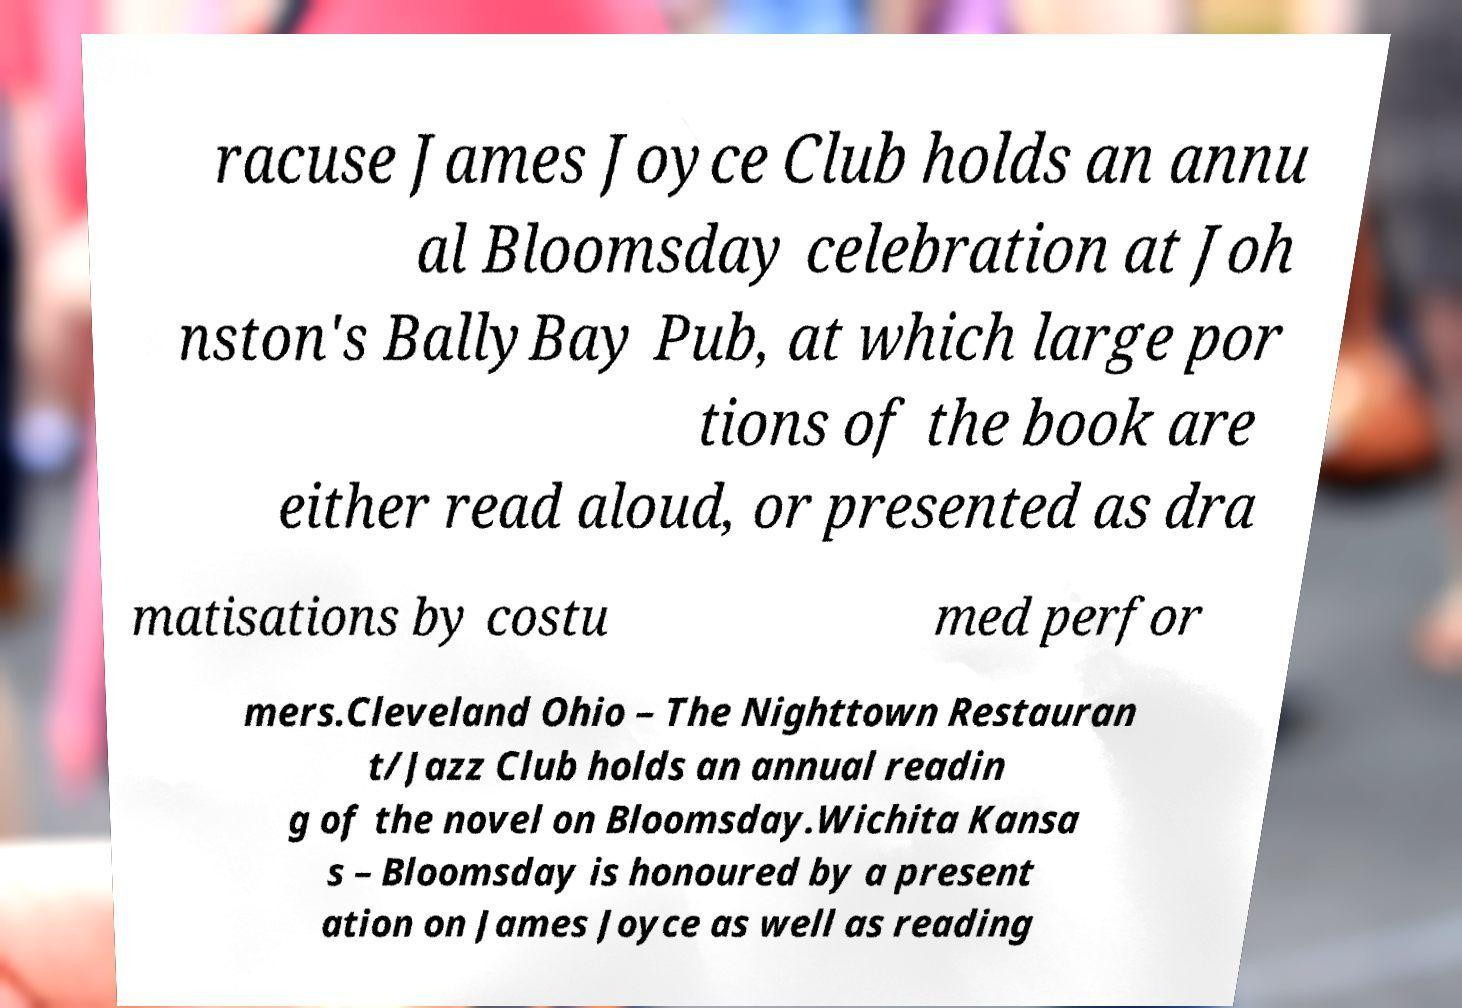There's text embedded in this image that I need extracted. Can you transcribe it verbatim? racuse James Joyce Club holds an annu al Bloomsday celebration at Joh nston's BallyBay Pub, at which large por tions of the book are either read aloud, or presented as dra matisations by costu med perfor mers.Cleveland Ohio – The Nighttown Restauran t/Jazz Club holds an annual readin g of the novel on Bloomsday.Wichita Kansa s – Bloomsday is honoured by a present ation on James Joyce as well as reading 